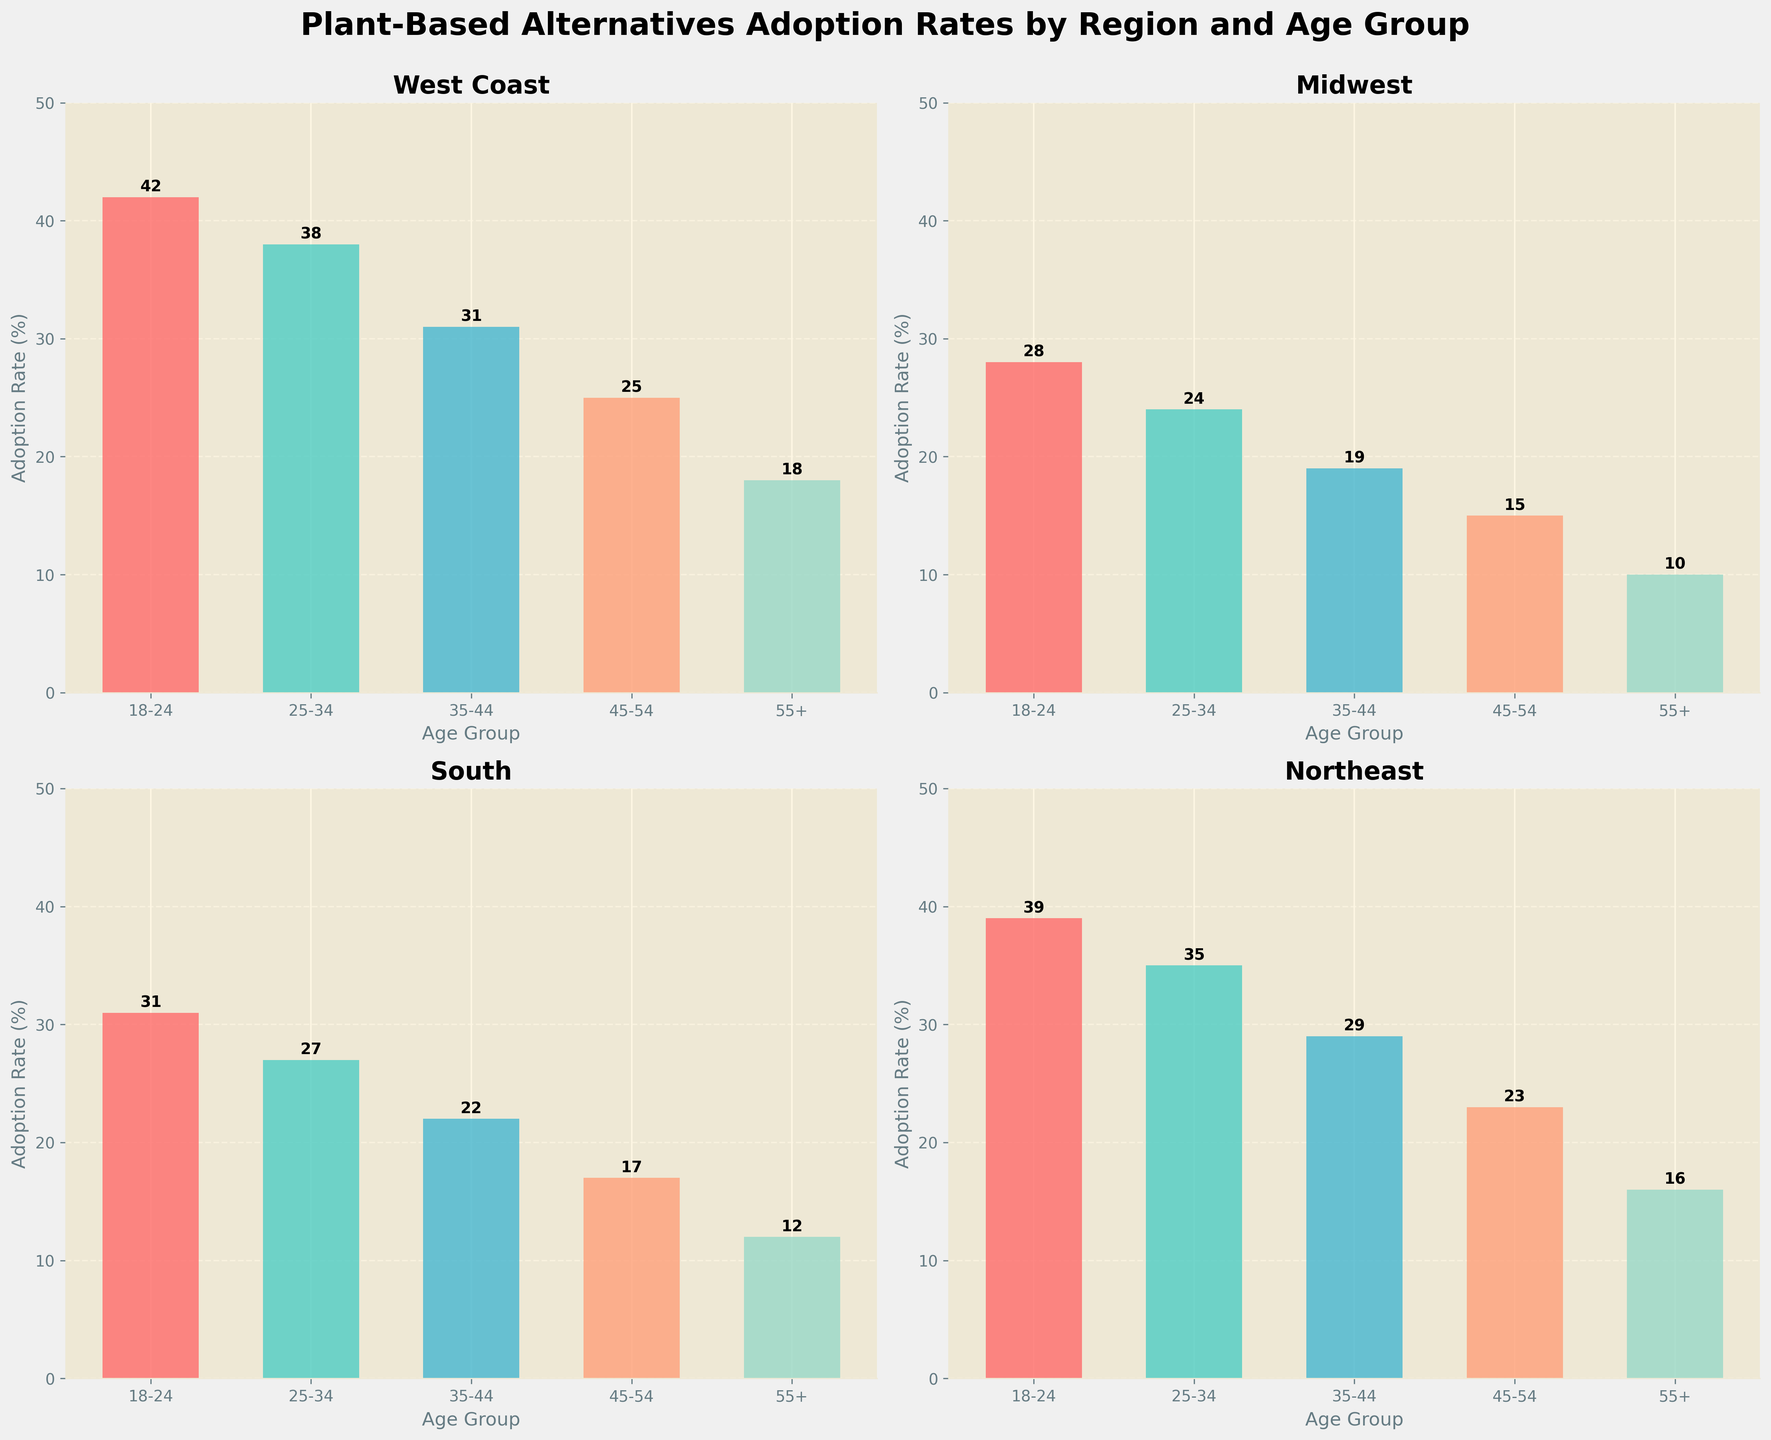How does the adoption rate differ between the West Coast and the Midwest for the 18-24 age group? In the figure, the adoption rate for the 18-24 age group in the West Coast is 42%, while in the Midwest, it is 28%. Subtracting the Midwest rate from the West Coast rate, we get 42% - 28% = 14%.
Answer: 14% Which region has the highest adoption rate for the 25-34 age group? By examining each subplot, we see that the West Coast has 38%, Midwest has 24%, South has 27%, and Northeast has 35% adoption rates for the 25-34 age group. The highest among these is the West Coast at 38%.
Answer: West Coast What is the overall trend in adoption rates as age increases in the South region? By looking at the South subplot, we observe the rates decrease steadily from 31% in the 18-24 age group, to 27% in 25-34, 22% in 35-44, 17% in 45-54, and finally to 12% in 55+. The trend is a clear decline.
Answer: Decreasing What is the average adoption rate for all age groups in the Northeast region? The adoption rates for the Northeast are 39%, 35%, 29%, 23%, and 16%. Summing these and dividing by the number of age groups gives (39 + 35 + 29 + 23 + 16) / 5 = 142 / 5 = 28.4%.
Answer: 28.4% Which age group has the smallest range of adoption rates across all regions? To find the range, we need to subtract the smallest adoption rate from the largest for each age group: 18-24: 42-28=14, 25-34: 38-24=14, 35-44: 31-19=12, 45-54: 25-15=10, 55+: 18-10=8. The smallest range is in the 55+ age group with a range of 8 percentage points.
Answer: 55+ How does the adoption rate for the 35-44 age group in the West Coast compare to the average adoption rate for all age groups in the West Coast? The adoption rates in the West Coast are: 42%, 38%, 31%, 25%, and 18%. The average is (42 + 38 + 31 + 25 + 18) / 5 = 154 / 5 = 30.8%. The 35-44 age group has an adoption rate of 31%, which is slightly above the average.
Answer: Slightly above the average Which region shows the steepest decline in adoption rates from the 18-24 age group to the 55+ age group? Subtracting the 55+ age group rates from the 18-24 age group in each region: West Coast: 42-18=24, Midwest: 28-10=18, South: 31-12=19, Northeast: 39-16=23. The West Coast shows the steepest decline of 24 percentage points.
Answer: West Coast 